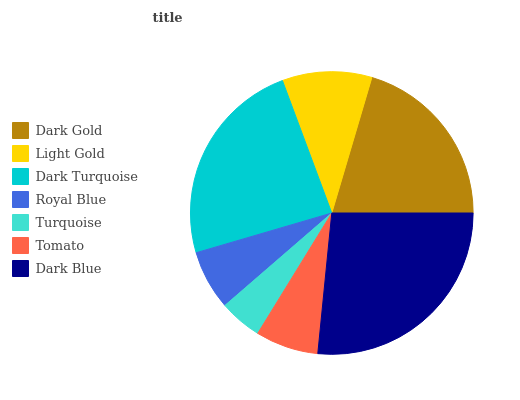Is Turquoise the minimum?
Answer yes or no. Yes. Is Dark Blue the maximum?
Answer yes or no. Yes. Is Light Gold the minimum?
Answer yes or no. No. Is Light Gold the maximum?
Answer yes or no. No. Is Dark Gold greater than Light Gold?
Answer yes or no. Yes. Is Light Gold less than Dark Gold?
Answer yes or no. Yes. Is Light Gold greater than Dark Gold?
Answer yes or no. No. Is Dark Gold less than Light Gold?
Answer yes or no. No. Is Light Gold the high median?
Answer yes or no. Yes. Is Light Gold the low median?
Answer yes or no. Yes. Is Royal Blue the high median?
Answer yes or no. No. Is Dark Blue the low median?
Answer yes or no. No. 